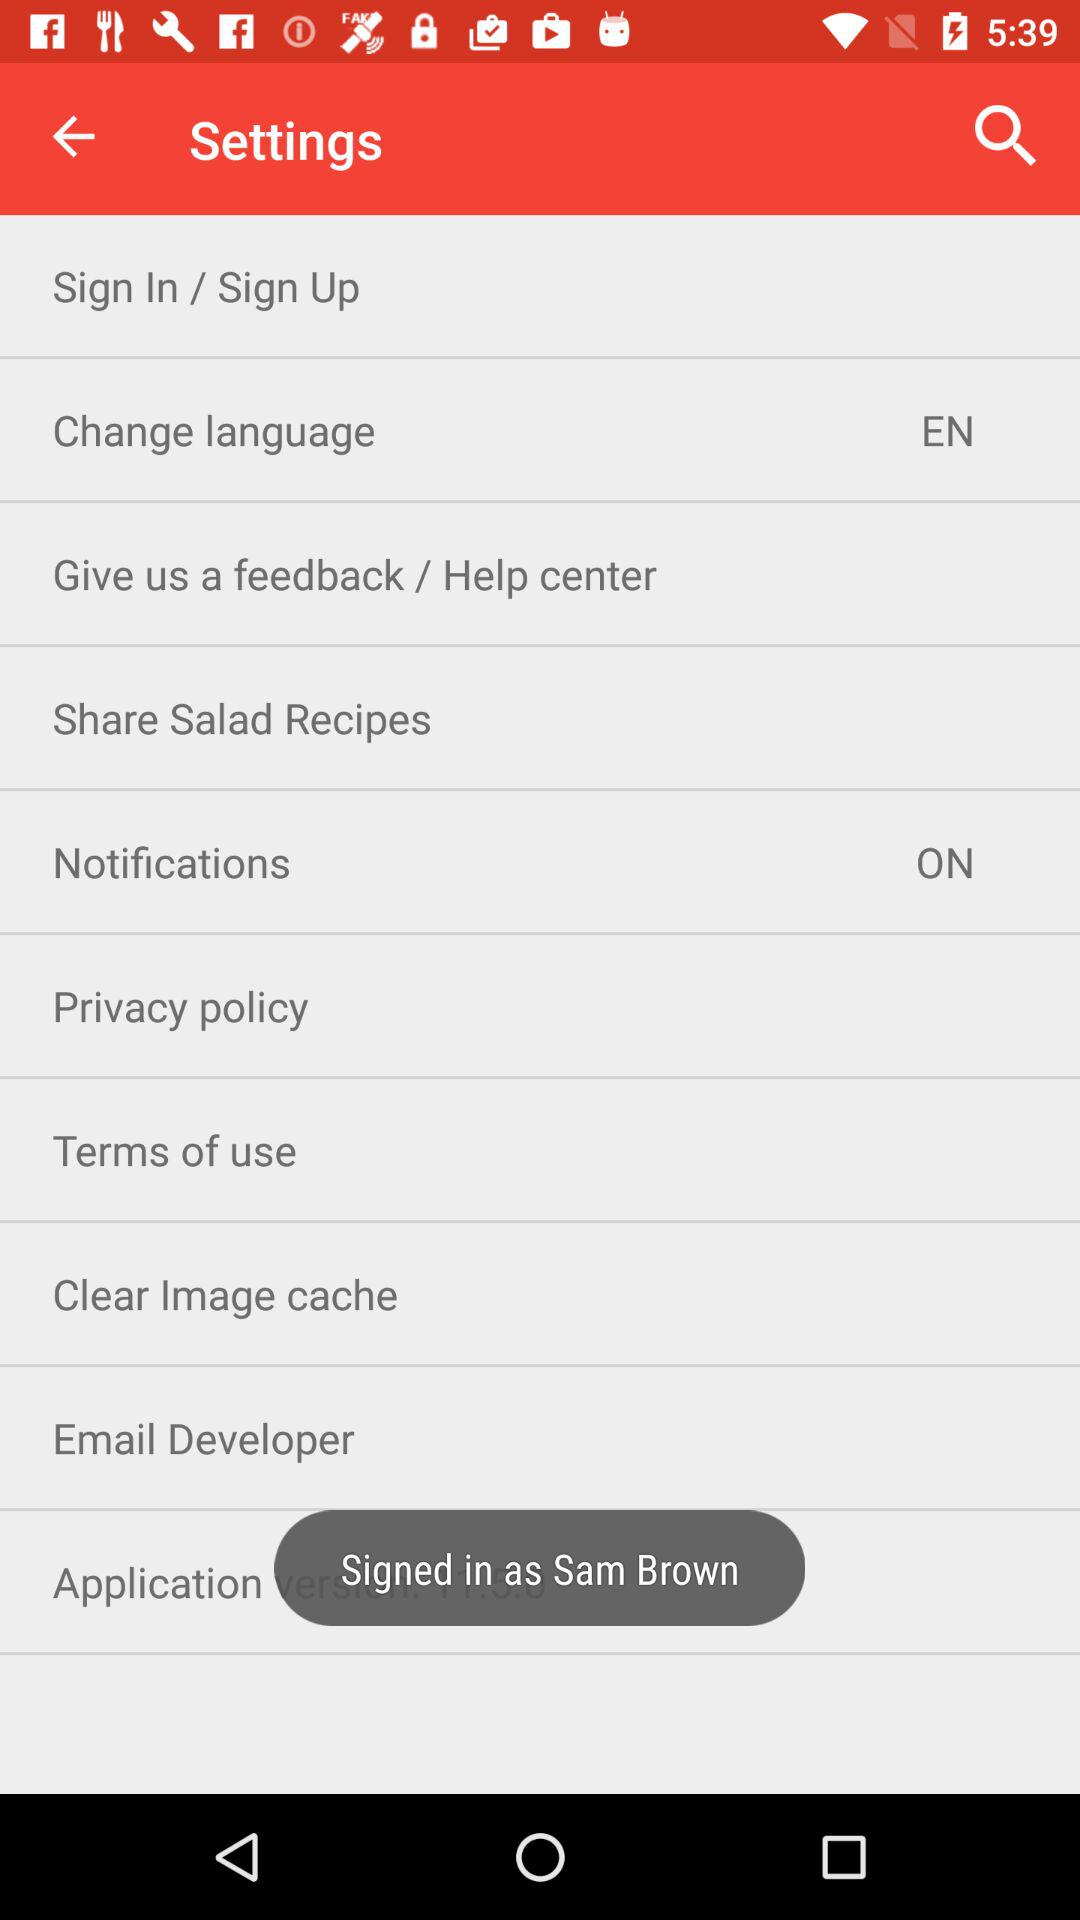What is the name of the user? The name of the user is Sam Brown. 